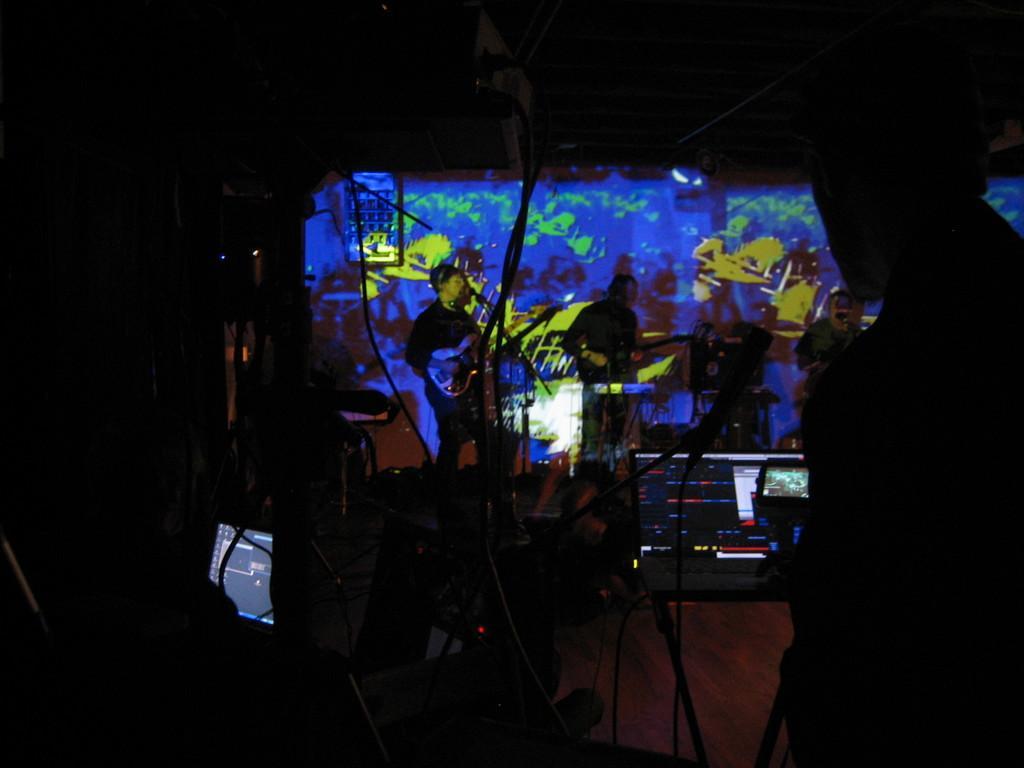Please provide a concise description of this image. In this image I can see few people standing and playing musical instruments. Front I can see few system,wires and some objects. Background is in blue and green color. The image is dark. 